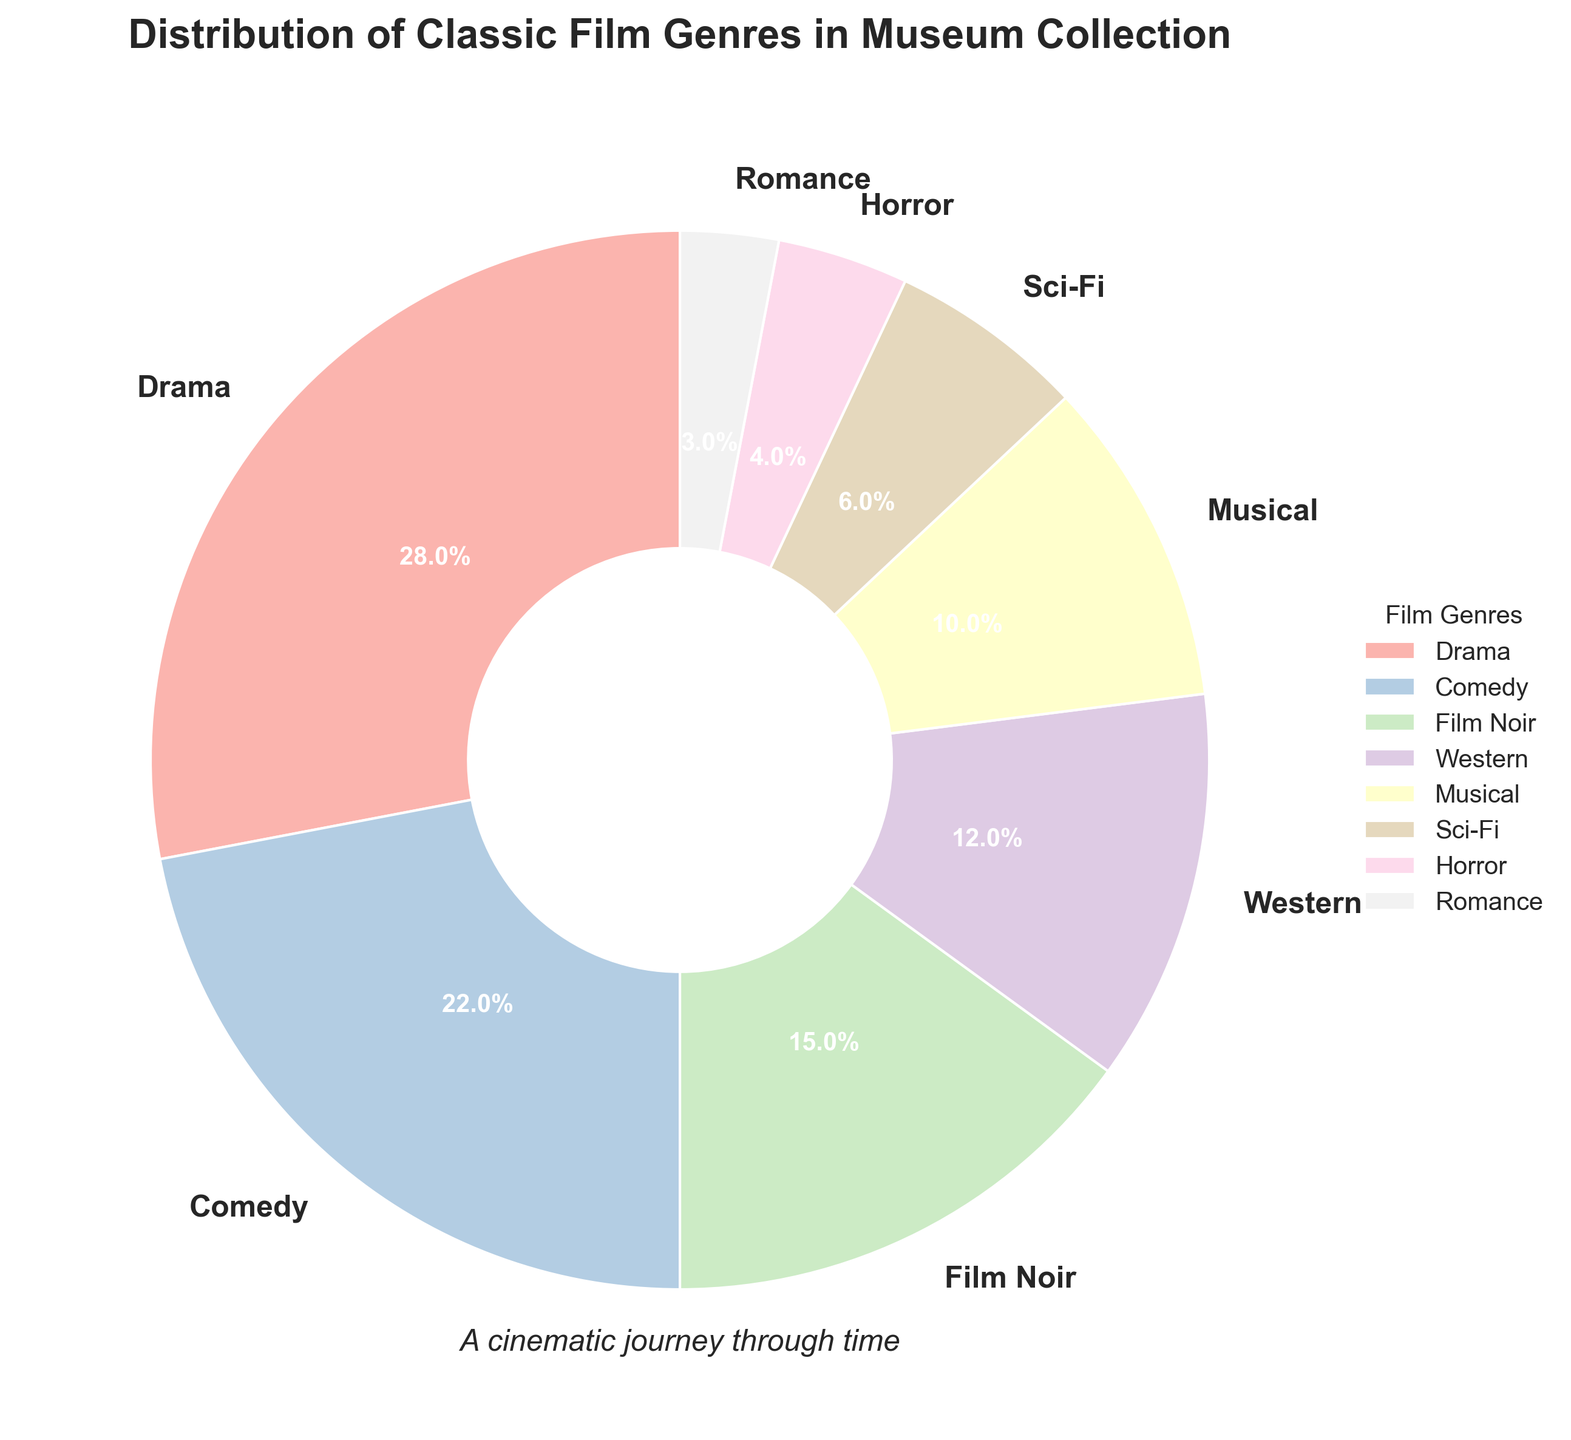What genre has the highest percentage in the pie chart? The pie chart shows different film genres and their corresponding percentages. By looking at the chart, the genre with the largest wedge is Drama at 28%.
Answer: Drama Which two genres together make up exactly one-quarter (25%) of the collection? By inspecting the wedges, we see Horror is 4% and Romance is 3%. Together, they make 7%, not 25%. Next, Sci-Fi is 6% and Musical is 10%, so that’s 16%. Checking Western at 12% and Musical at 10%, we get 22%. Finally, Film Noir at 15% and Romance at 3% together make 18%. The correct pair is Sci-Fi (6%) and Horror (4%), which sum to 10%. None of the pairs sum exactly to 25%.
Answer: None Which genre has a larger percentage: Comedy or Western? By visually comparing the size of the wedges for Comedy and Western, we see that Comedy has a wedge marked with 22% and Western has a wedge marked with 12%. Therefore, Comedy has a larger percentage.
Answer: Comedy What is the total percentage of genres that each have less than 10%? The genres with less than 10% are Sci-Fi (6%), Horror (4%), and Romance (3%). Adding these percentages together: 6% + 4% + 3% equals 13%.
Answer: 13% How many genres contribute to more than 15% of the collection? By looking at the chart, the genres and their percentages are: Drama (28%), Comedy (22%), and Film Noir (15%). Only Drama and Comedy exceed 15%.
Answer: 2 What is the ratio of the percentage of Drama to Musical? Drama has 28% and Musical has 10%. To find the ratio: 28 / 10 equals 2.8.
Answer: 2.8 If we combine Film Noir and Musical, how does their combined percentage compare to Western? Film Noir is 15% and Musical is 10%. Adding these gives 25%. Western alone is 12%. So, 25% (Film Noir + Musical) is greater than 12% (Western).
Answer: Film Noir and Musical combined are greater Which genre occupies the smallest percentage in the collection? Looking at the sizes of the wedges, Romance has the smallest percentage, marked with 3%.
Answer: Romance 